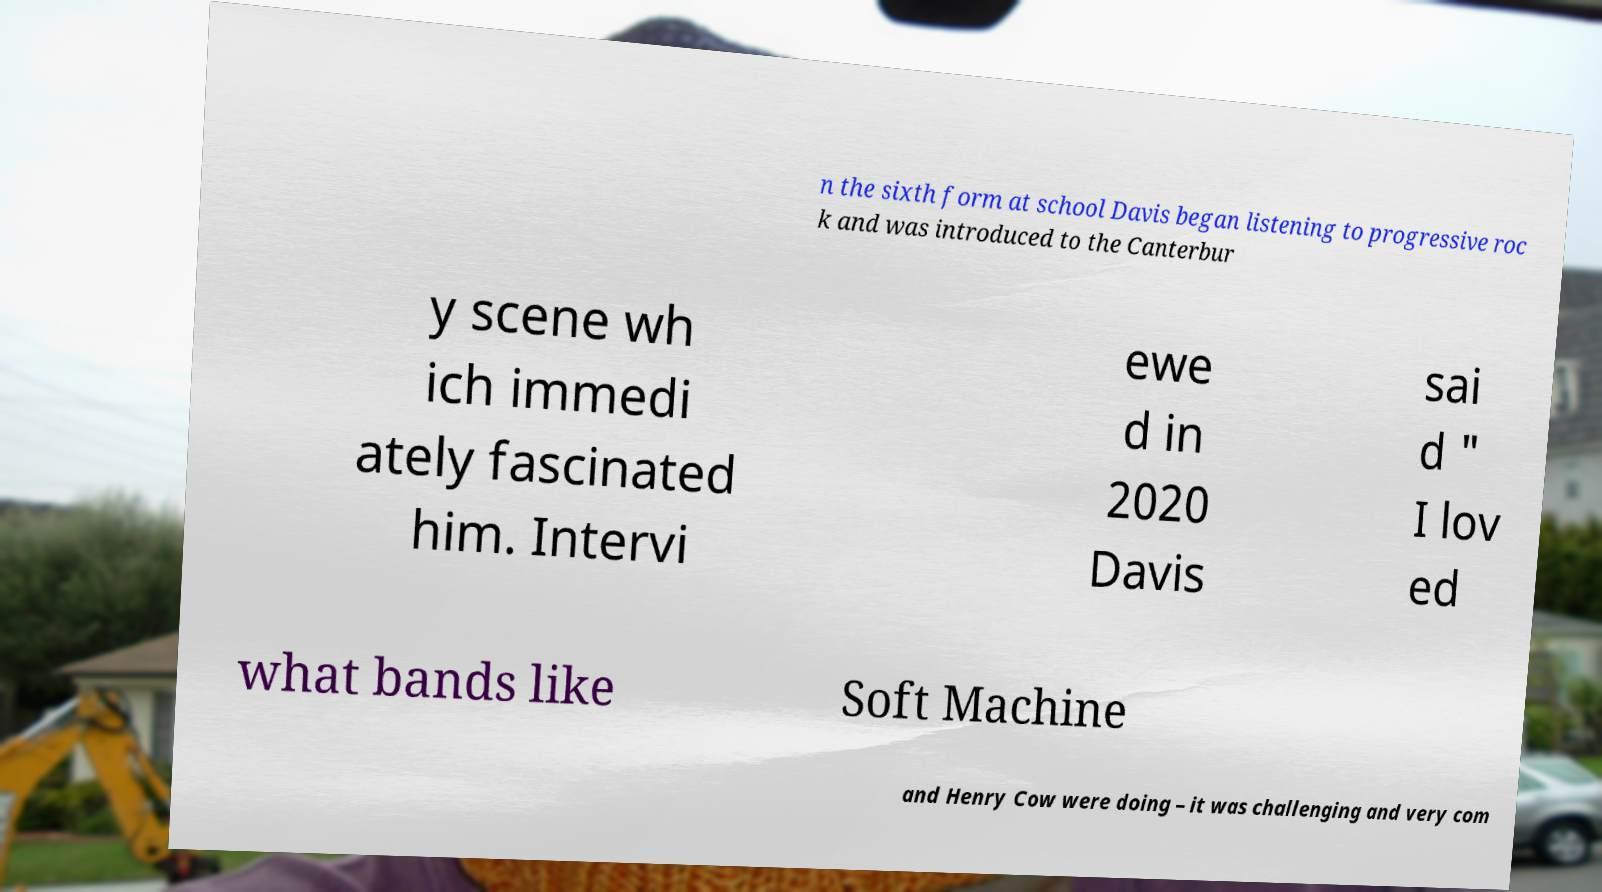There's text embedded in this image that I need extracted. Can you transcribe it verbatim? n the sixth form at school Davis began listening to progressive roc k and was introduced to the Canterbur y scene wh ich immedi ately fascinated him. Intervi ewe d in 2020 Davis sai d " I lov ed what bands like Soft Machine and Henry Cow were doing – it was challenging and very com 